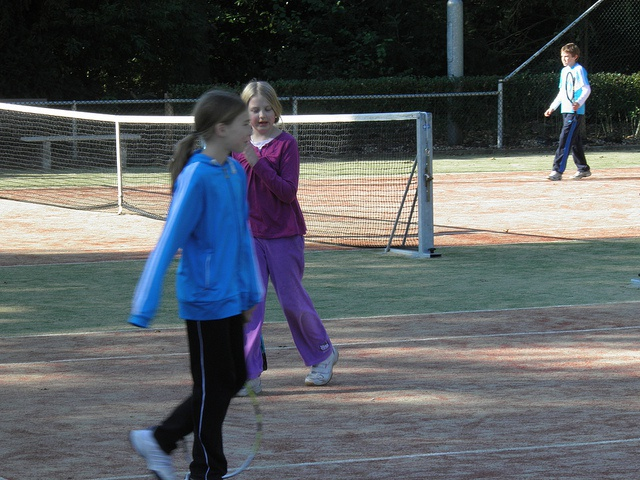Describe the objects in this image and their specific colors. I can see people in black, blue, gray, and navy tones, people in black, navy, purple, and gray tones, people in black, white, gray, and navy tones, tennis racket in black and gray tones, and bench in black, gray, and purple tones in this image. 